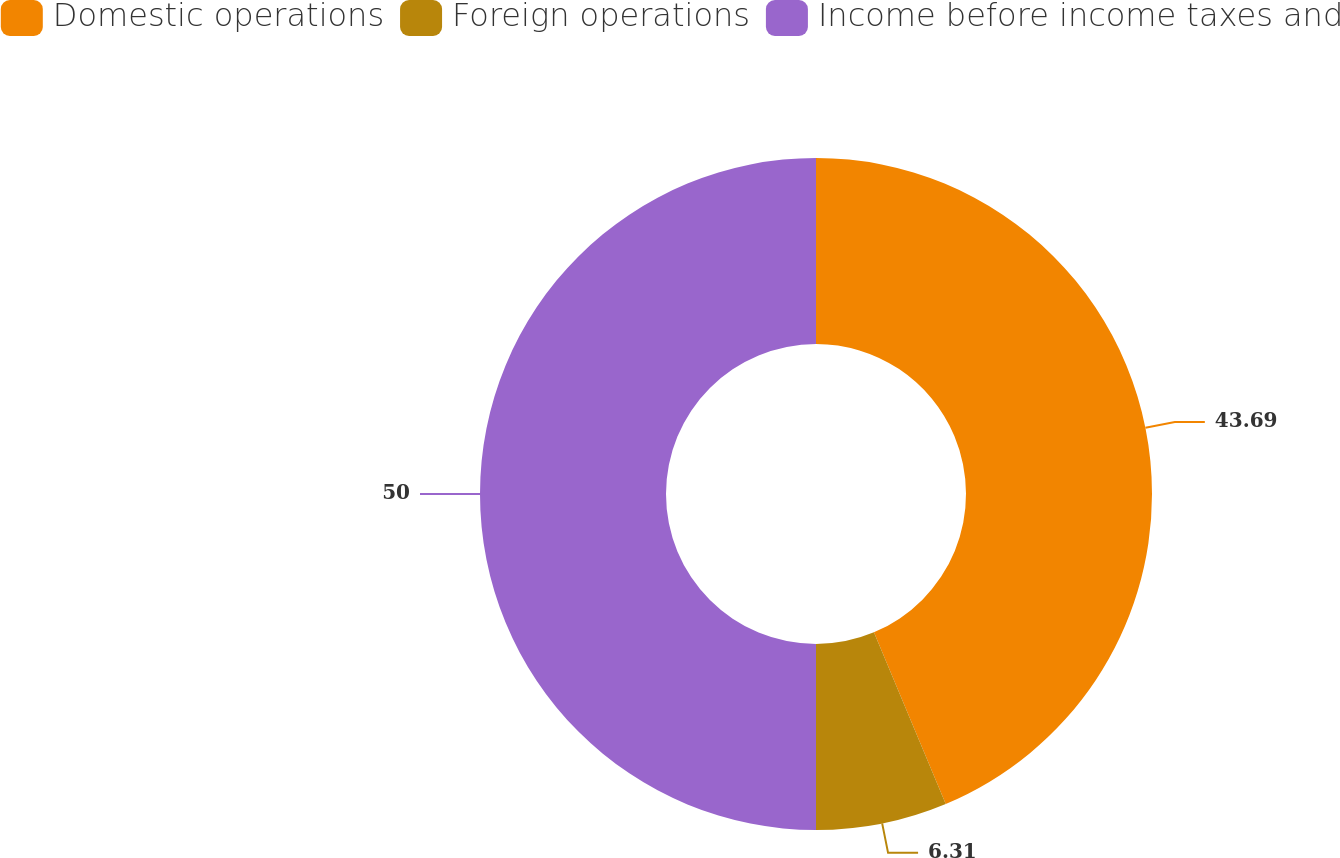Convert chart to OTSL. <chart><loc_0><loc_0><loc_500><loc_500><pie_chart><fcel>Domestic operations<fcel>Foreign operations<fcel>Income before income taxes and<nl><fcel>43.69%<fcel>6.31%<fcel>50.0%<nl></chart> 